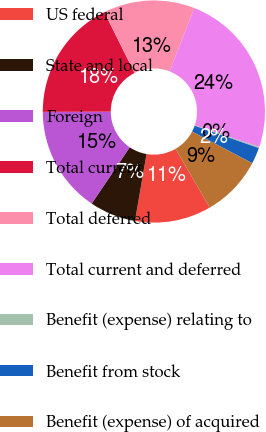Convert chart to OTSL. <chart><loc_0><loc_0><loc_500><loc_500><pie_chart><fcel>US federal<fcel>State and local<fcel>Foreign<fcel>Total current<fcel>Total deferred<fcel>Total current and deferred<fcel>Benefit (expense) relating to<fcel>Benefit from stock<fcel>Benefit (expense) of acquired<nl><fcel>11.11%<fcel>6.74%<fcel>15.49%<fcel>17.68%<fcel>13.3%<fcel>24.24%<fcel>0.17%<fcel>2.36%<fcel>8.92%<nl></chart> 